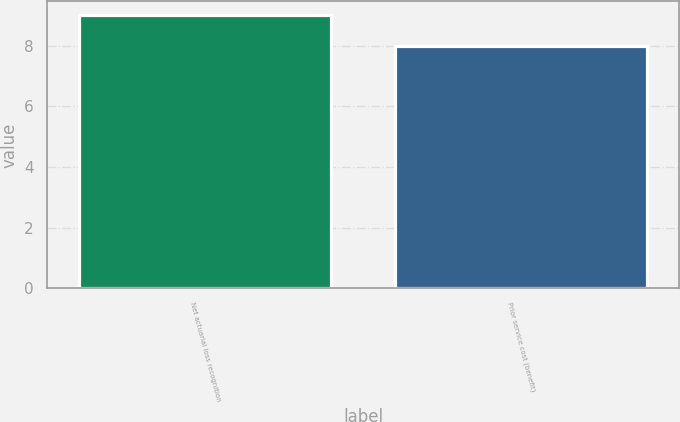Convert chart to OTSL. <chart><loc_0><loc_0><loc_500><loc_500><bar_chart><fcel>Net actuarial loss recognition<fcel>Prior service cost (benefit)<nl><fcel>9<fcel>8<nl></chart> 